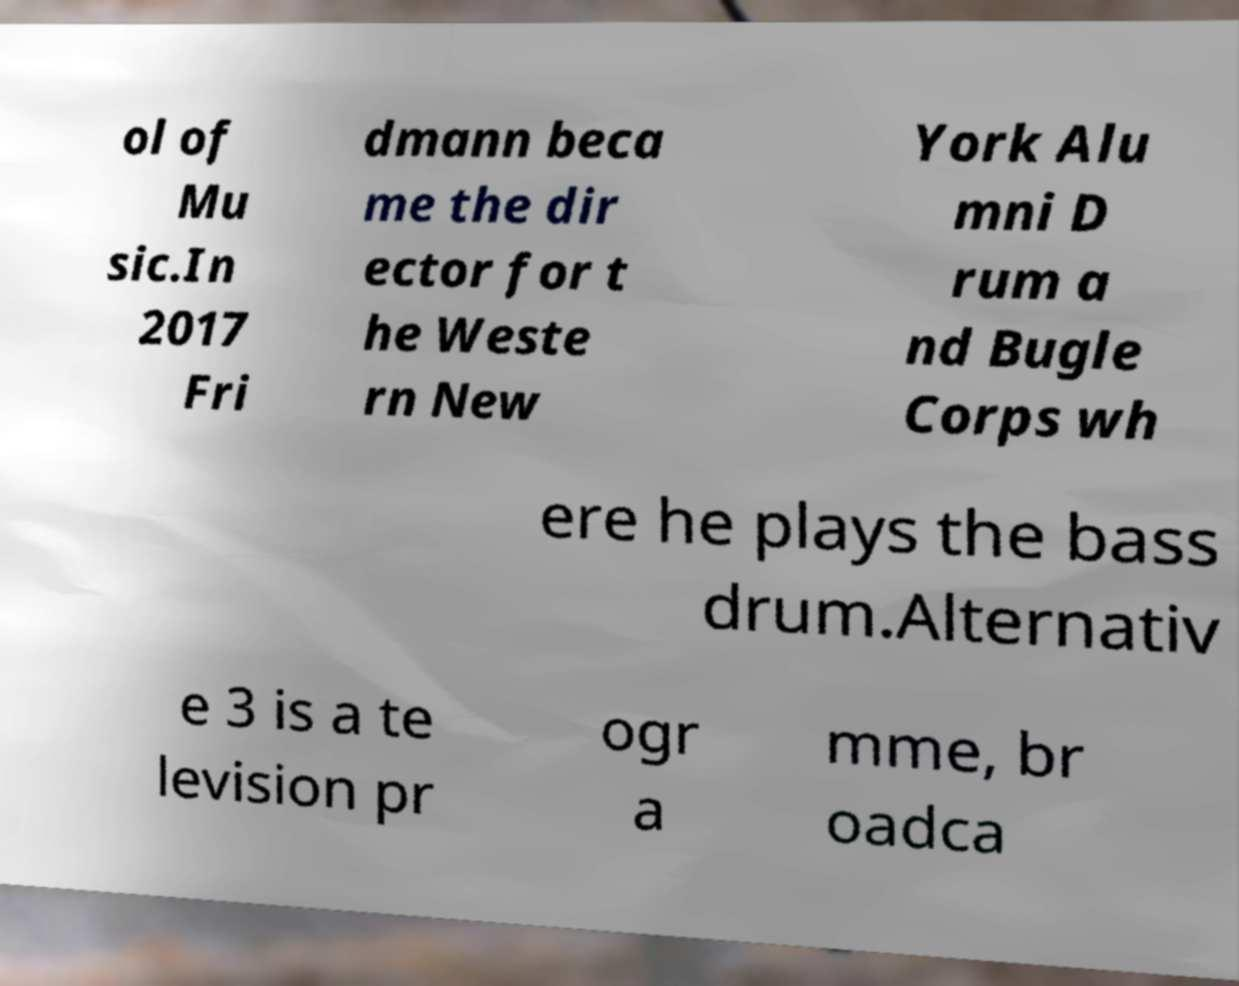Please identify and transcribe the text found in this image. ol of Mu sic.In 2017 Fri dmann beca me the dir ector for t he Weste rn New York Alu mni D rum a nd Bugle Corps wh ere he plays the bass drum.Alternativ e 3 is a te levision pr ogr a mme, br oadca 